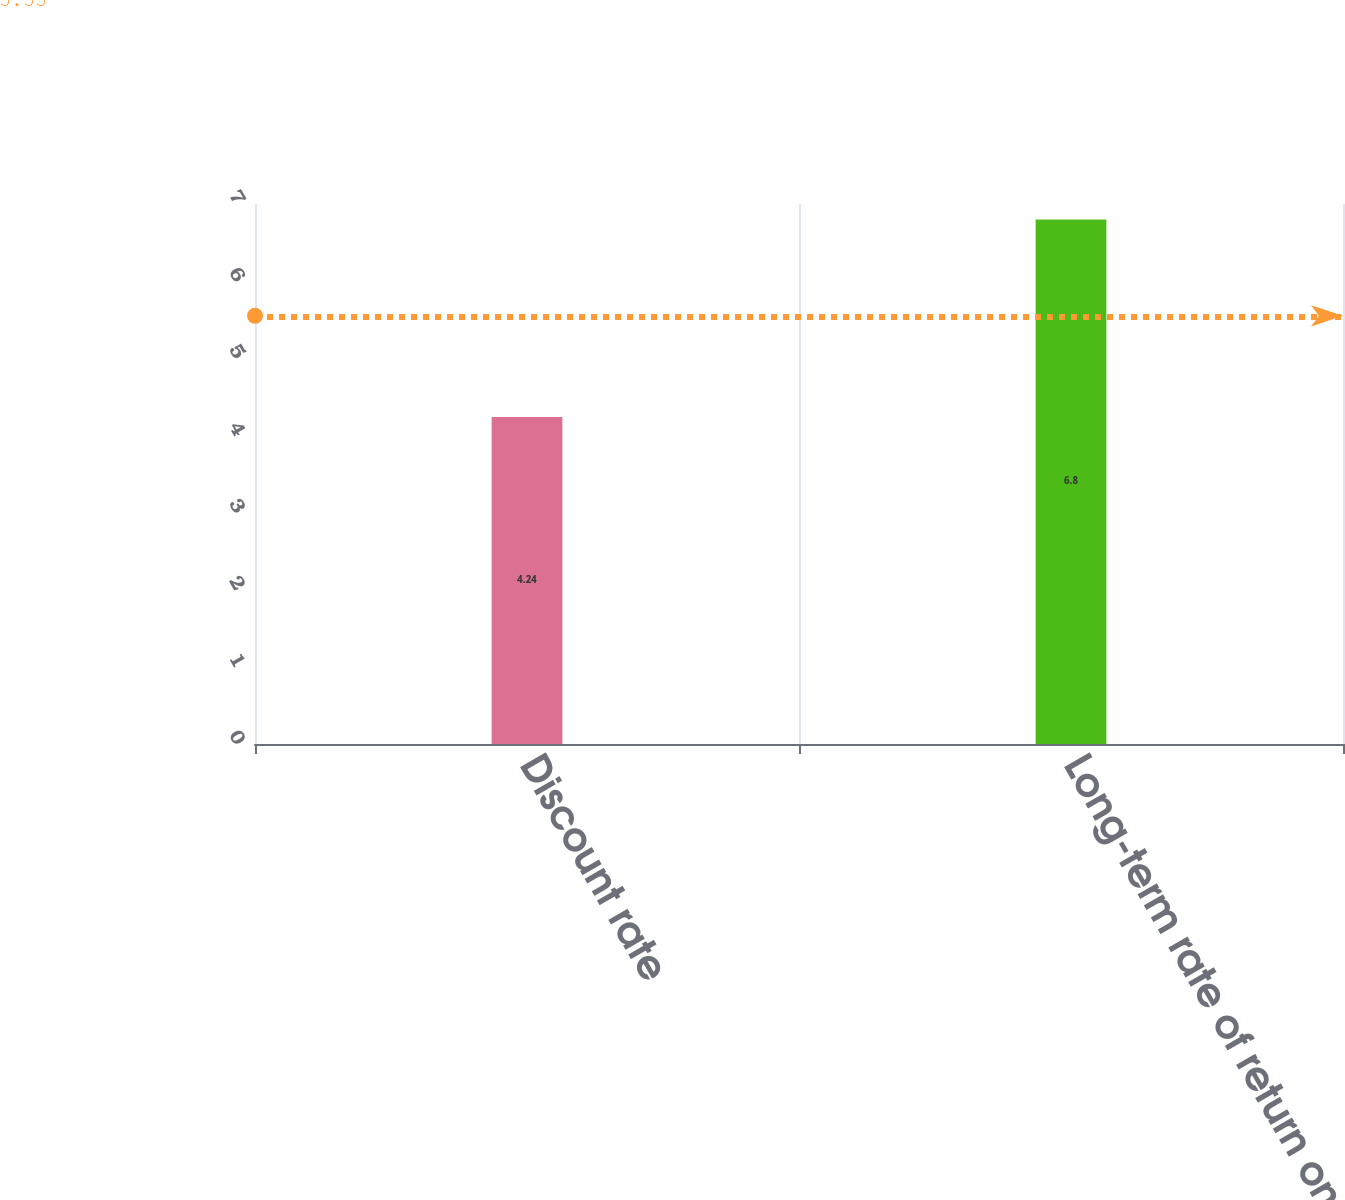Convert chart to OTSL. <chart><loc_0><loc_0><loc_500><loc_500><bar_chart><fcel>Discount rate<fcel>Long-term rate of return on<nl><fcel>4.24<fcel>6.8<nl></chart> 